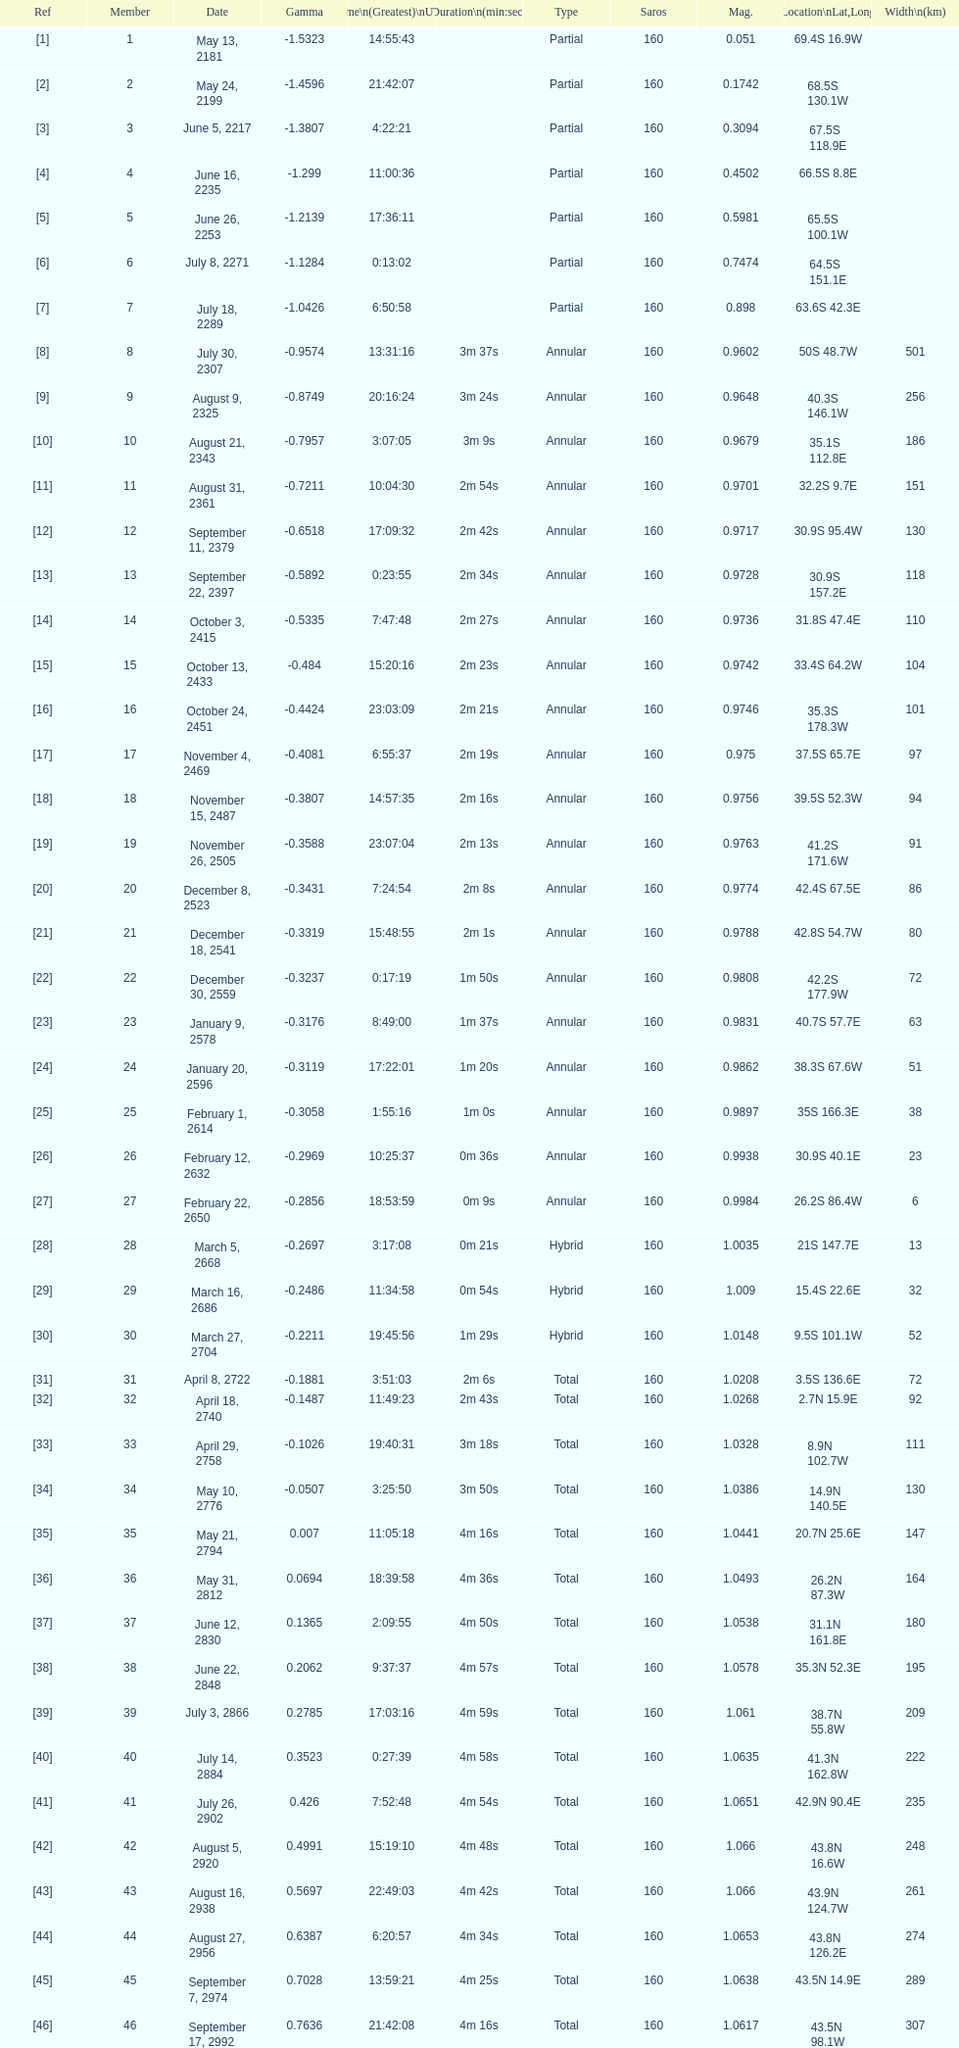Name a member number with a latitude above 60 s. 1. 